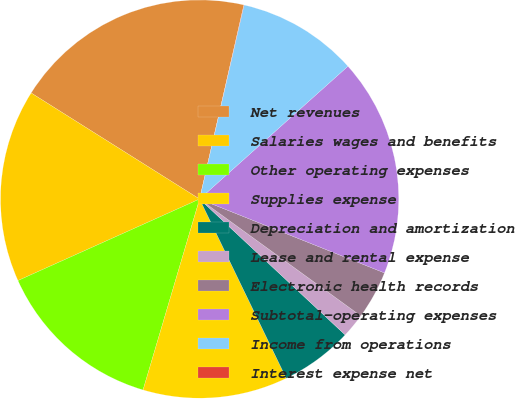<chart> <loc_0><loc_0><loc_500><loc_500><pie_chart><fcel>Net revenues<fcel>Salaries wages and benefits<fcel>Other operating expenses<fcel>Supplies expense<fcel>Depreciation and amortization<fcel>Lease and rental expense<fcel>Electronic health records<fcel>Subtotal-operating expenses<fcel>Income from operations<fcel>Interest expense net<nl><fcel>19.62%<fcel>15.66%<fcel>13.7%<fcel>11.75%<fcel>5.88%<fcel>1.97%<fcel>3.93%<fcel>17.67%<fcel>9.79%<fcel>0.02%<nl></chart> 